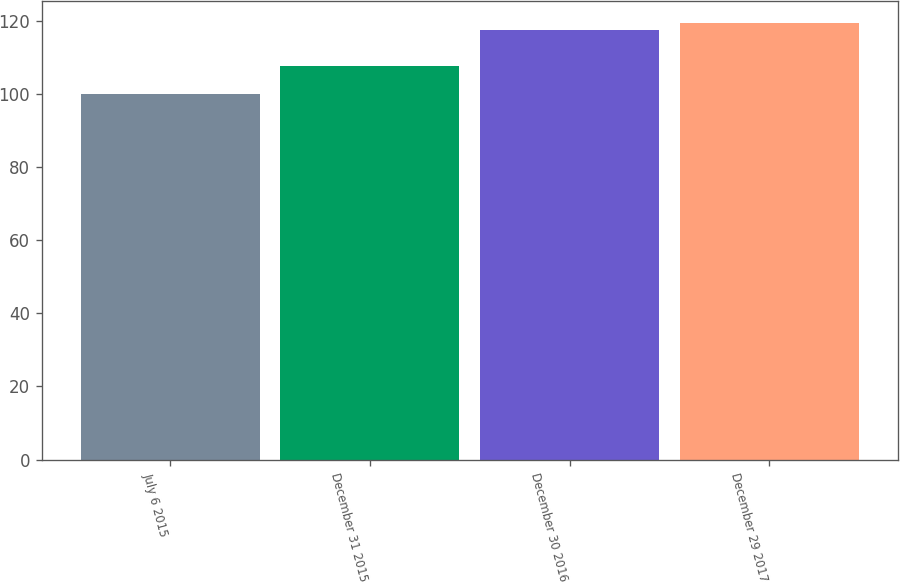<chart> <loc_0><loc_0><loc_500><loc_500><bar_chart><fcel>July 6 2015<fcel>December 31 2015<fcel>December 30 2016<fcel>December 29 2017<nl><fcel>100<fcel>107.48<fcel>117.49<fcel>119.38<nl></chart> 